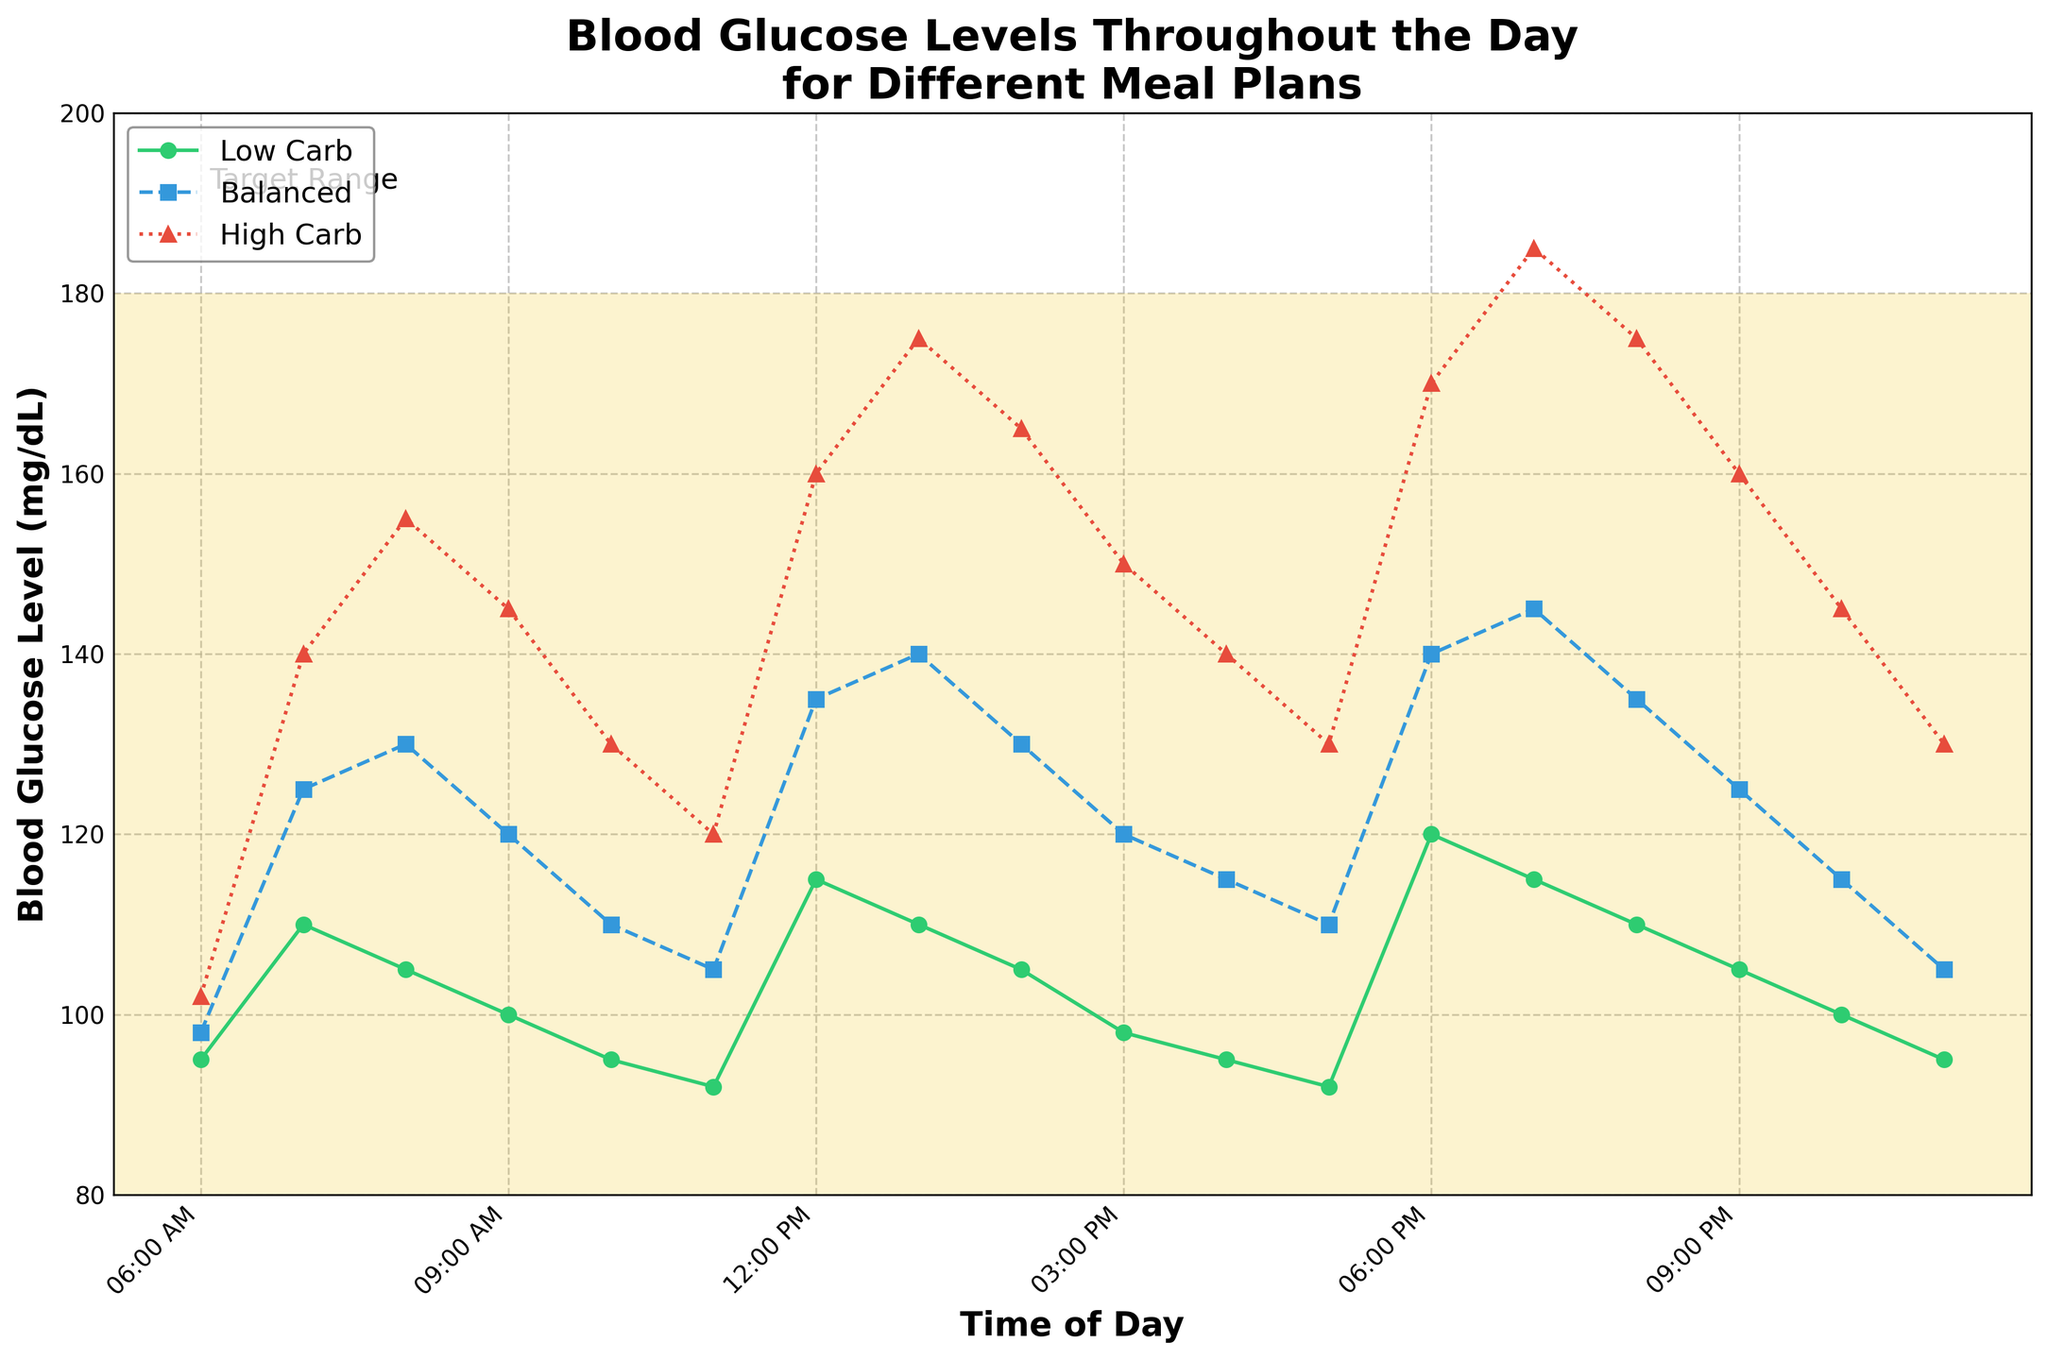What time does the Low Carb Meal Plan show the highest blood glucose level? The highest point for the Low Carb Meal Plan is at its peak on the y-axis. Observing the low-carb line, this peak occurs at 6:00 PM with a value of 120 mg/dL.
Answer: 6:00 PM During which hour does the High Carb Meal Plan show the biggest drop in blood glucose levels? Look for the steepest descending slope on the High Carb line (red) on the chart. The biggest drop is between 8:00 PM (175 mg/dL) and 9:00 PM (160 mg/dL), a difference of 15 mg/dL.
Answer: Between 8:00 PM and 9:00 PM Are blood glucose levels for the Balanced Meal Plan ever higher than both the other meal plans? Compare the blue Balanced Meal Plan line with the green Low Carb and red High Carb lines. At 1:00 PM, the Balanced Meal Plan peaks at 140 mg/dL which is higher than the Low Carb (110 mg/dL) but lower than High Carb (175 mg/dL). Therefore, it's never higher than both simultaneously.
Answer: No Which meal plan maintains the most stable blood glucose levels throughout the day? Look for the line with the least fluctuations. The Low Carb Meal Plan (green line) has the smallest vertical changes, indicating stable blood glucose levels.
Answer: Low Carb Meal Plan At 10:00 AM, how does the blood glucose level of the Balanced Meal Plan compare to that of the High Carb Meal Plan? At 10:00 AM, the blue line representing the Balanced Meal Plan is at 110 mg/dL, whereas the red line representing the High Carb Meal Plan is at 130 mg/dL. The Balanced Meal Plan has a lower blood glucose level.
Answer: Lower What is the average blood glucose level for the High Carb Meal Plan at 7:00 AM, 12:00 PM, and 6:00 PM? Add the values for the High Carb Meal Plan at these times: 140 mg/dL (7:00 AM), 160 mg/dL (12:00 PM), and 170 mg/dL (6:00 PM). Sum is 140 + 160 + 170 = 470. Divide by 3 to get the average: 470 / 3 ≈ 156.67 mg/dL.
Answer: 156.67 mg/dL Which meal plan has the lowest blood glucose level by the end of the day at 11:00 PM? Look at 11:00 PM and compare the positions of the three lines. The green Low Carb Meal Plan line is at 95 mg/dL, which is lower than the Balanced (105 mg/dL) and High Carb (130 mg/dL) lines.
Answer: Low Carb Meal Plan How do the blood glucose levels compare for all meal plans at noon (12:00 PM)? Check the y-axis values for all three lines at 12:00 PM. The Low Carb Meal Plan is at 115 mg/dL, the Balanced Meal Plan at 135 mg/dL, and the High Carb Meal Plan at 160 mg/dL. The Low Carb is the lowest, followed by Balanced, and the highest is High Carb.
Answer: Low Carb < Balanced < High Carb 